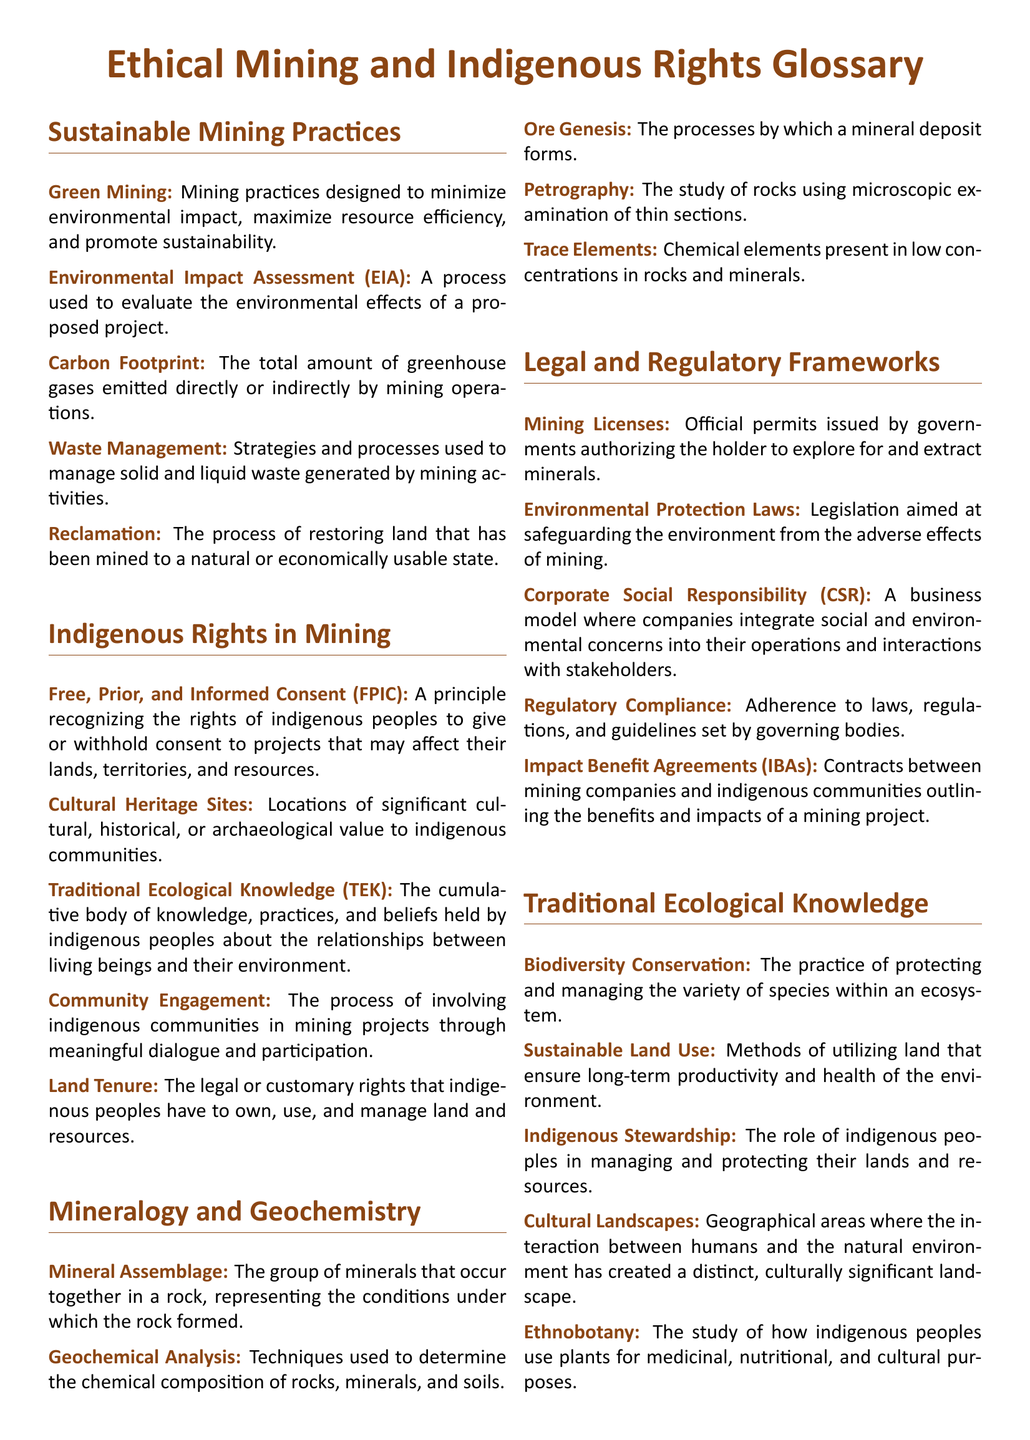What is the principle recognizing indigenous rights? The principle that acknowledges the rights of indigenous peoples to consent to projects affecting their lands and resources is outlined in the term Free, Prior, and Informed Consent.
Answer: Free, Prior, and Informed Consent (FPIC) What does EIA stand for? EIA stands for Environmental Impact Assessment, which evaluates the effects of proposed projects.
Answer: Environmental Impact Assessment (EIA) What is used to determine chemical composition in geochemistry? Geochemical Analysis is the technique mentioned in the document for determining the chemical composition of rocks, minerals, and soils.
Answer: Geochemical Analysis What are contracts outlining benefits between mining companies and communities called? The term related to contracts between mining companies and indigenous communities that outline benefits and impacts is Impact Benefit Agreements.
Answer: Impact Benefit Agreements (IBAs) Which practice protects biodiversity within ecosystems? Biodiversity Conservation is the practice aimed at protecting and managing the variety of species within an ecosystem.
Answer: Biodiversity Conservation What term refers to the group of minerals in a rock? The term that defines the group of minerals occurring together in a rock is Mineral Assemblage.
Answer: Mineral Assemblage What legal rights do indigenous peoples have over land? Land Tenure refers to the legal or customary rights that indigenous peoples have concerning land and resources.
Answer: Land Tenure What is the purpose of Corporate Social Responsibility? The purpose of Corporate Social Responsibility involves integrating social and environmental concerns into business operations.
Answer: Corporate Social Responsibility (CSR) How do sustainable mining practices aim to minimize effects? Green Mining refers to mining practices designed to minimize environmental impact while promoting sustainability.
Answer: Green Mining 